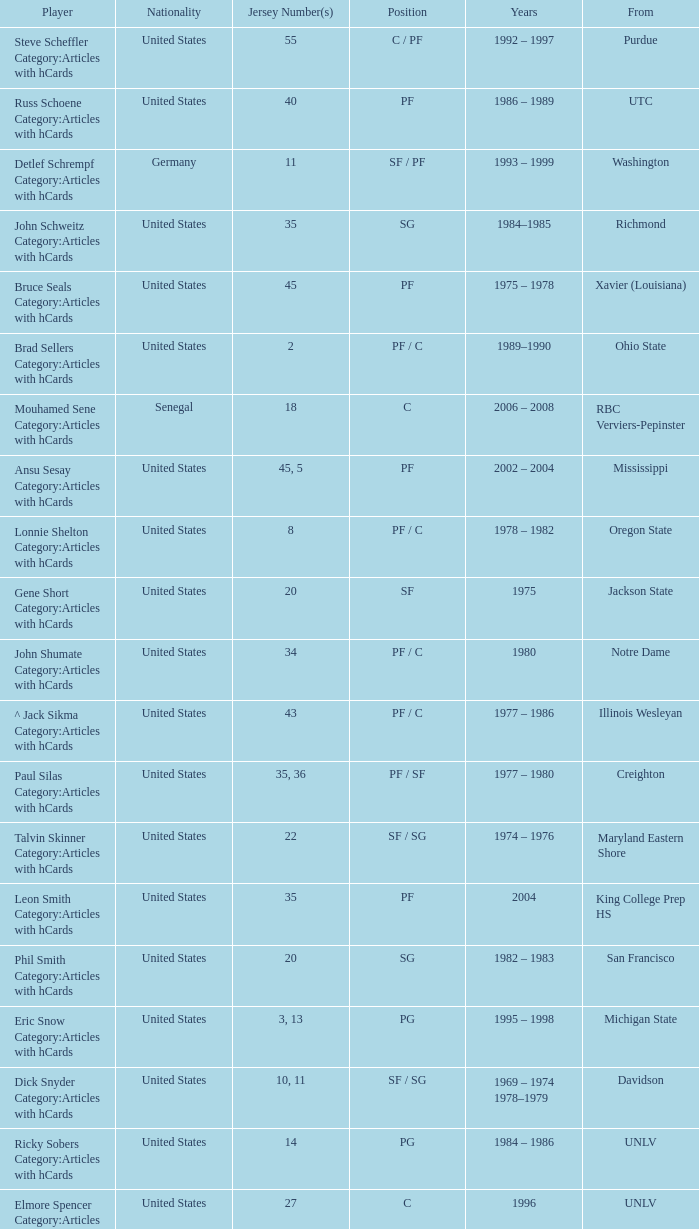What position does the player with jersey number 22 play? SF / SG. 